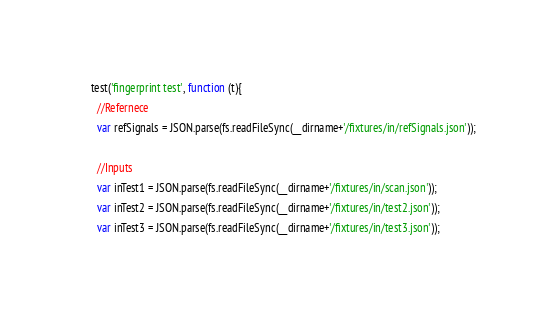<code> <loc_0><loc_0><loc_500><loc_500><_JavaScript_>    test('fingerprint test', function (t){
      //Refernece
      var refSignals = JSON.parse(fs.readFileSync(__dirname+'/fixtures/in/refSignals.json'));

      //Inputs
      var inTest1 = JSON.parse(fs.readFileSync(__dirname+'/fixtures/in/scan.json'));
      var inTest2 = JSON.parse(fs.readFileSync(__dirname+'/fixtures/in/test2.json'));
      var inTest3 = JSON.parse(fs.readFileSync(__dirname+'/fixtures/in/test3.json'));</code> 